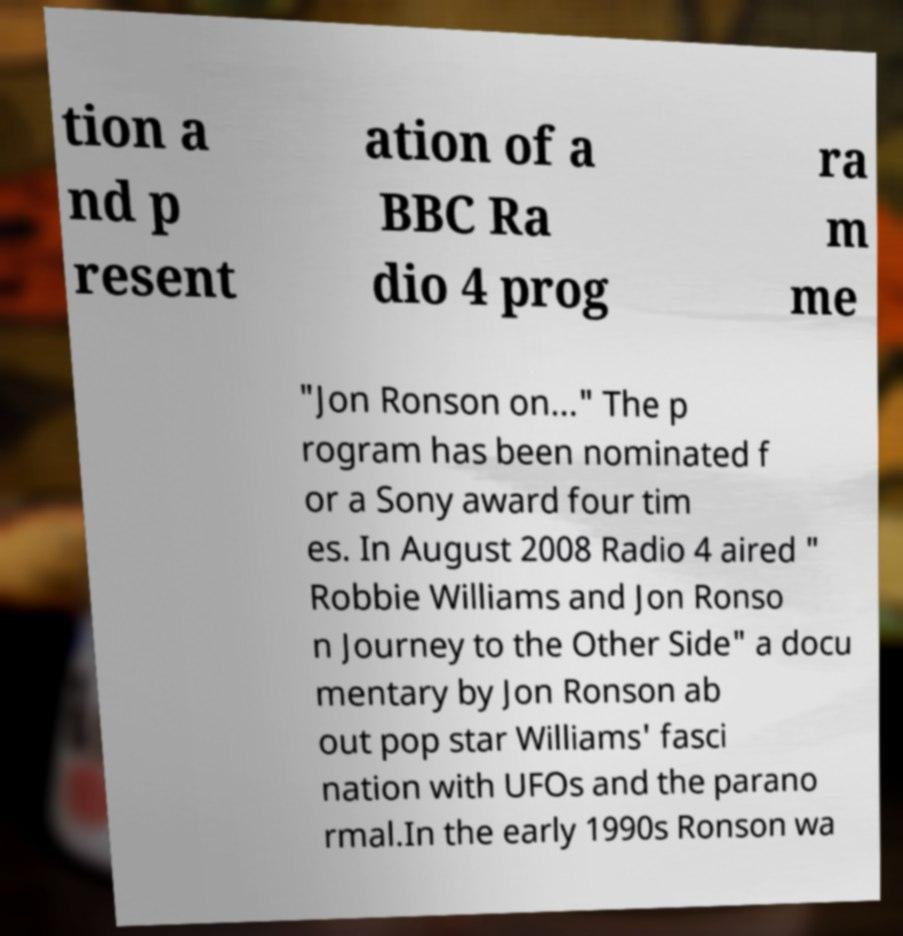There's text embedded in this image that I need extracted. Can you transcribe it verbatim? tion a nd p resent ation of a BBC Ra dio 4 prog ra m me "Jon Ronson on..." The p rogram has been nominated f or a Sony award four tim es. In August 2008 Radio 4 aired " Robbie Williams and Jon Ronso n Journey to the Other Side" a docu mentary by Jon Ronson ab out pop star Williams' fasci nation with UFOs and the parano rmal.In the early 1990s Ronson wa 